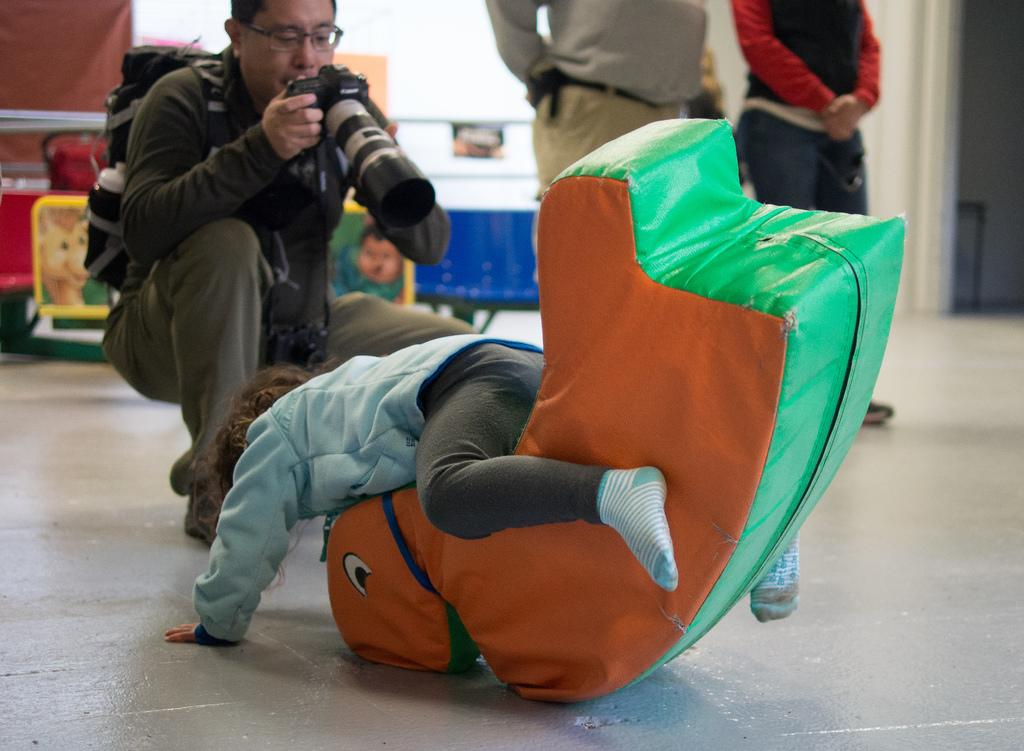What is the man in the image doing? The man is holding a camera and taking a picture. Who else is present in the image besides the man? There is a kid in the image. How many people are standing in the image? There are two persons standing in the image. What crime is the man committing in the image? There is no indication of a crime being committed in the image; the man is simply taking a picture. Is the kid in the image the man's brother? The relationship between the man and the kid is not mentioned in the image, so we cannot determine if they are related. 